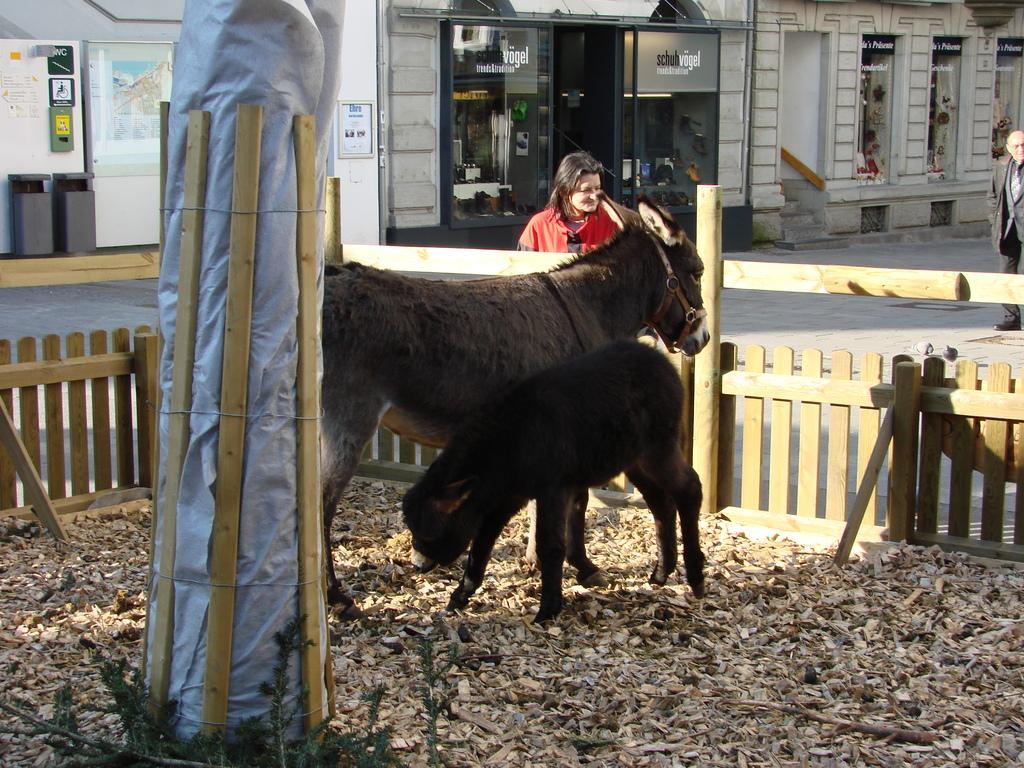Could you give a brief overview of what you see in this image? In this image in the center there are two animals, and there is a fence. At the bottom there are some plants and some dry leaves and on the left side there are some poles, and there is a plastic cover and in the background there are some buildings and some boards. On the boards there is text and one person is walking, and at the bottom there is a walkway. 